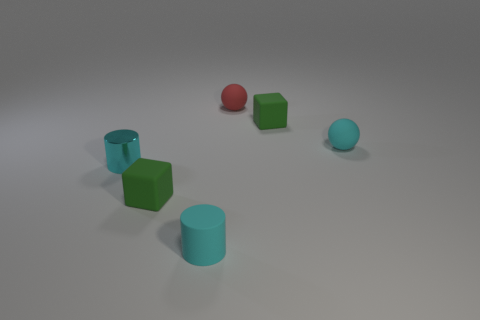What material is the other cylinder that is the same color as the tiny matte cylinder?
Offer a terse response. Metal. What number of rubber cylinders have the same color as the tiny metal cylinder?
Provide a succinct answer. 1. There is a small cylinder to the right of the shiny object; is it the same color as the tiny shiny object in front of the small cyan matte ball?
Your response must be concise. Yes. What size is the cylinder that is the same color as the metal thing?
Keep it short and to the point. Small. Is there anything else that is the same color as the small matte cylinder?
Provide a succinct answer. Yes. Does the tiny rubber cylinder have the same color as the metallic cylinder?
Ensure brevity in your answer.  Yes. Is the tiny cube in front of the cyan metallic object made of the same material as the cylinder behind the rubber cylinder?
Your answer should be very brief. No. There is another thing that is the same shape as the red thing; what is its material?
Ensure brevity in your answer.  Rubber. There is a tiny rubber object that is on the left side of the small cyan matte object left of the small red ball; what is its color?
Ensure brevity in your answer.  Green. What size is the ball that is the same material as the tiny red object?
Your response must be concise. Small. 